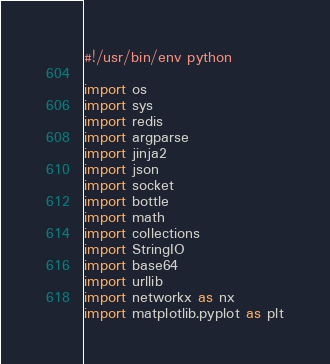<code> <loc_0><loc_0><loc_500><loc_500><_Python_>#!/usr/bin/env python

import os
import sys
import redis
import argparse
import jinja2
import json
import socket
import bottle
import math
import collections
import StringIO
import base64
import urllib
import networkx as nx
import matplotlib.pyplot as plt
</code> 